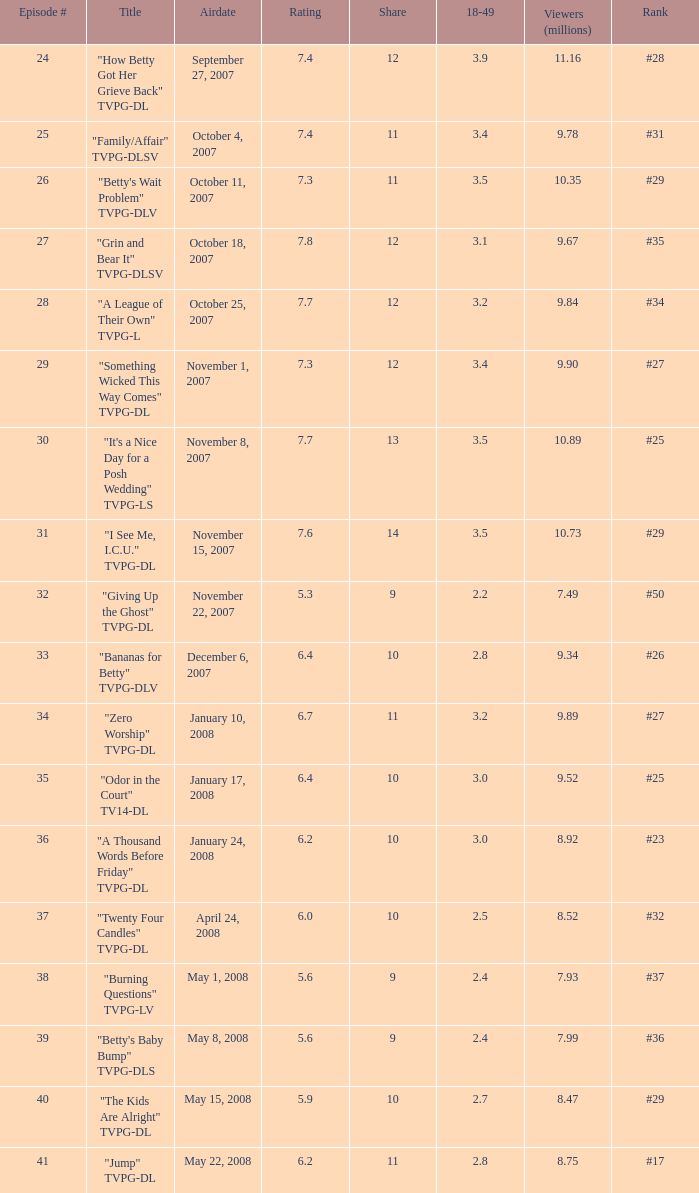Can you give me this table as a dict? {'header': ['Episode #', 'Title', 'Airdate', 'Rating', 'Share', '18-49', 'Viewers (millions)', 'Rank'], 'rows': [['24', '"How Betty Got Her Grieve Back" TVPG-DL', 'September 27, 2007', '7.4', '12', '3.9', '11.16', '#28'], ['25', '"Family/Affair" TVPG-DLSV', 'October 4, 2007', '7.4', '11', '3.4', '9.78', '#31'], ['26', '"Betty\'s Wait Problem" TVPG-DLV', 'October 11, 2007', '7.3', '11', '3.5', '10.35', '#29'], ['27', '"Grin and Bear It" TVPG-DLSV', 'October 18, 2007', '7.8', '12', '3.1', '9.67', '#35'], ['28', '"A League of Their Own" TVPG-L', 'October 25, 2007', '7.7', '12', '3.2', '9.84', '#34'], ['29', '"Something Wicked This Way Comes" TVPG-DL', 'November 1, 2007', '7.3', '12', '3.4', '9.90', '#27'], ['30', '"It\'s a Nice Day for a Posh Wedding" TVPG-LS', 'November 8, 2007', '7.7', '13', '3.5', '10.89', '#25'], ['31', '"I See Me, I.C.U." TVPG-DL', 'November 15, 2007', '7.6', '14', '3.5', '10.73', '#29'], ['32', '"Giving Up the Ghost" TVPG-DL', 'November 22, 2007', '5.3', '9', '2.2', '7.49', '#50'], ['33', '"Bananas for Betty" TVPG-DLV', 'December 6, 2007', '6.4', '10', '2.8', '9.34', '#26'], ['34', '"Zero Worship" TVPG-DL', 'January 10, 2008', '6.7', '11', '3.2', '9.89', '#27'], ['35', '"Odor in the Court" TV14-DL', 'January 17, 2008', '6.4', '10', '3.0', '9.52', '#25'], ['36', '"A Thousand Words Before Friday" TVPG-DL', 'January 24, 2008', '6.2', '10', '3.0', '8.92', '#23'], ['37', '"Twenty Four Candles" TVPG-DL', 'April 24, 2008', '6.0', '10', '2.5', '8.52', '#32'], ['38', '"Burning Questions" TVPG-LV', 'May 1, 2008', '5.6', '9', '2.4', '7.93', '#37'], ['39', '"Betty\'s Baby Bump" TVPG-DLS', 'May 8, 2008', '5.6', '9', '2.4', '7.99', '#36'], ['40', '"The Kids Are Alright" TVPG-DL', 'May 15, 2008', '5.9', '10', '2.7', '8.47', '#29'], ['41', '"Jump" TVPG-DL', 'May 22, 2008', '6.2', '11', '2.8', '8.75', '#17']]} When was the episode with a ranking of #29 and a share exceeding 10 aired? May 15, 2008. 